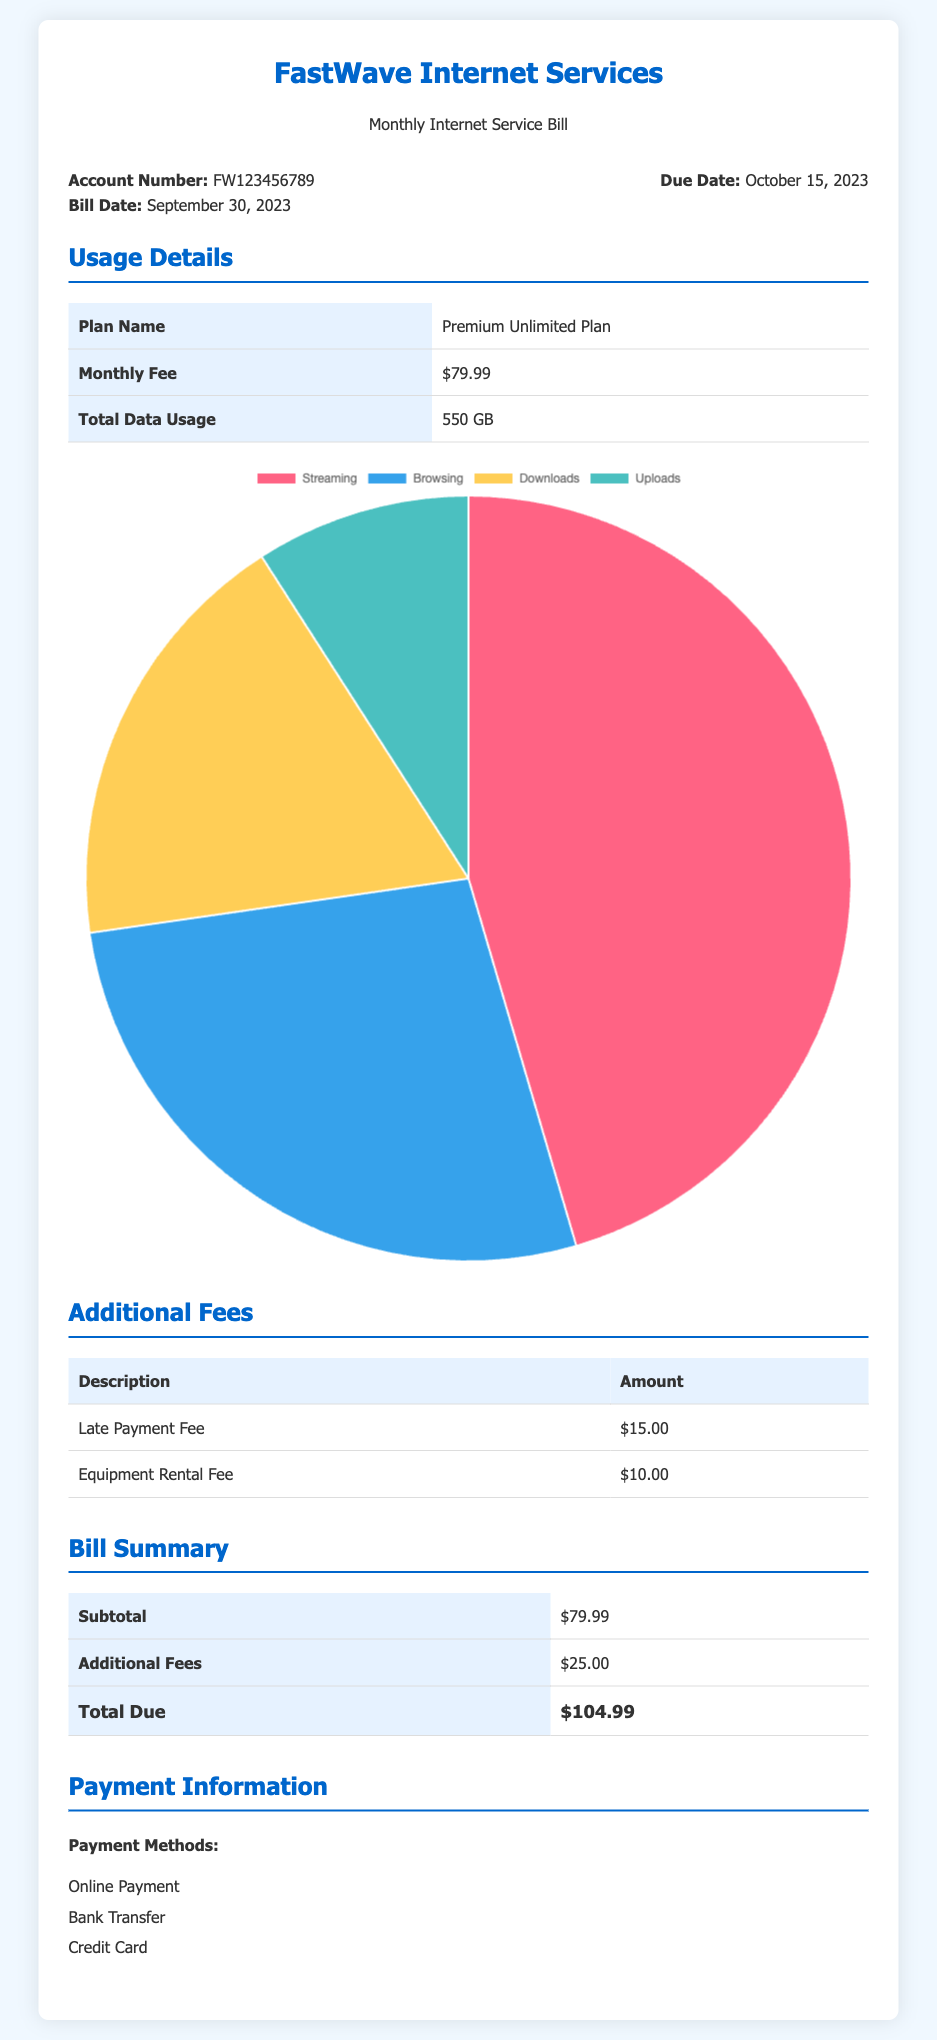What is the account number? The account number is listed near the top of the document.
Answer: FW123456789 What is the due date for the bill? The due date is clearly stated in the bill information section.
Answer: October 15, 2023 How much is the monthly fee for the internet plan? The monthly fee is shown in the usage details section of the document.
Answer: $79.99 What is the total data usage for September 2023? The total data usage is listed in the usage details section.
Answer: 550 GB What is the total due amount for the bill? The total due is calculated in the bill summary section.
Answer: $104.99 What fees are included in the additional fees section? The additional fees section lists specific fees charged in this billing period.
Answer: Late Payment Fee, Equipment Rental Fee How much is the equipment rental fee? The equipment rental fee is specifically detailed in the additional fees table.
Answer: $10.00 What is the total amount of additional fees? The total amount for additional fees is summarized in the bill summary section.
Answer: $25.00 Which payment methods are mentioned? The payment methods are listed in the payment information section of the document.
Answer: Online Payment, Bank Transfer, Credit Card 